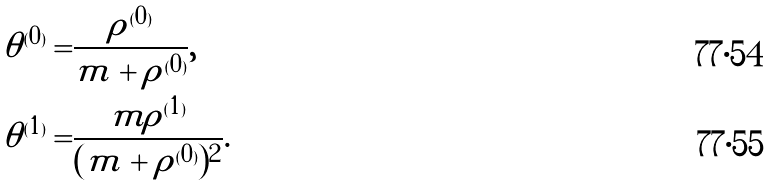<formula> <loc_0><loc_0><loc_500><loc_500>\theta ^ { ( 0 ) } = & \frac { \rho ^ { ( 0 ) } } { m + \rho ^ { ( 0 ) } } , \\ \theta ^ { ( 1 ) } = & \frac { m \rho ^ { ( 1 ) } } { ( m + \rho ^ { ( 0 ) } ) ^ { 2 } } .</formula> 